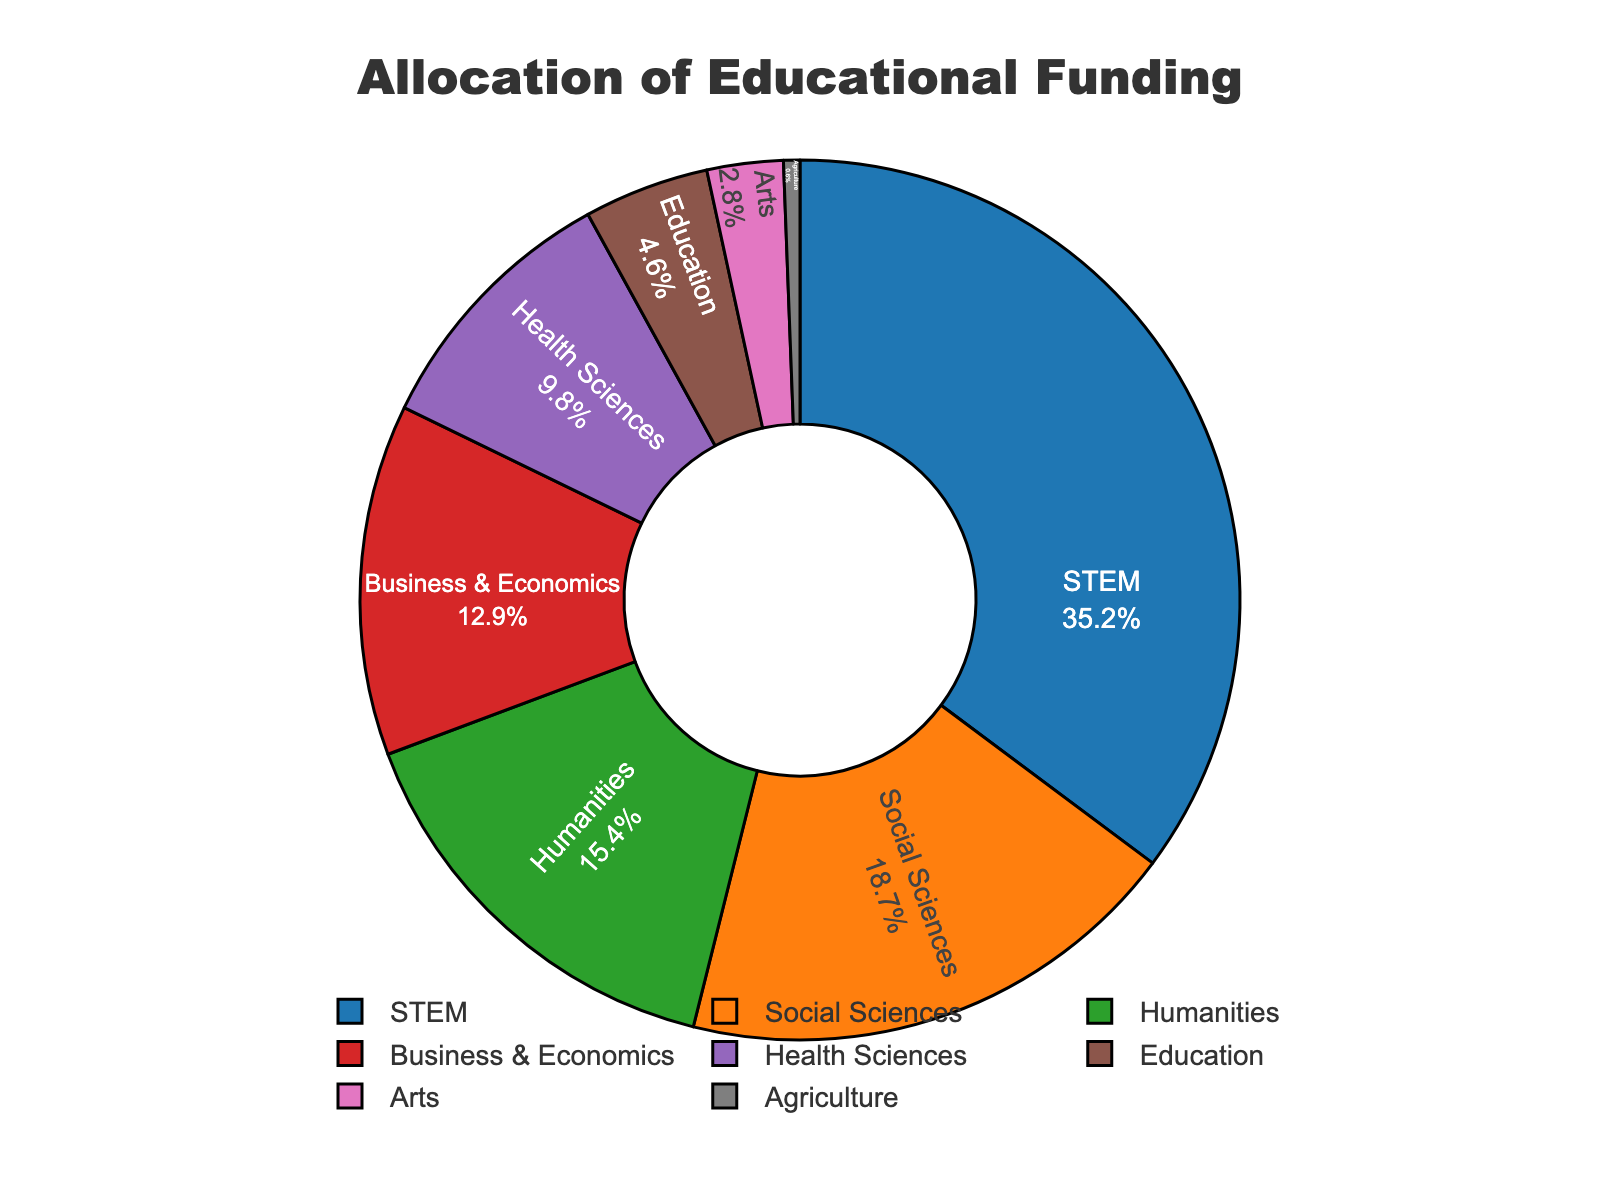Which discipline receives the highest percentage of educational funding? From the pie chart, the discipline with the largest slice is clearly labeled as STEM. Therefore, STEM receives the highest percentage of educational funding.
Answer: STEM What is the total percentage of funding allocated to the Social Sciences and Humanities combined? To find the combined percentage for Social Sciences and Humanities, add their individual percentages: 18.7% (Social Sciences) + 15.4% (Humanities) = 34.1%.
Answer: 34.1% How much more funding does the STEM discipline receive compared to Health Sciences? Subtract the percentage for Health Sciences from that for STEM: 35.2% (STEM) - 9.8% (Health Sciences) = 25.4%.
Answer: 25.4% What is the least-funded discipline and its percentage of the total allocation? The smallest slice in the pie chart is labeled Agriculture with the smallest percentage. The figure shows it receives 0.6% of the total allocation.
Answer: Agriculture, 0.6% Considering the disciplines of Business & Economics and Education, which one receives more funding and by how much? Compare the percentages for Business & Economics and Education: 12.9% (Business & Economics) and 4.6% (Education). To find the difference, subtract 4.6% from 12.9%: 12.9% - 4.6% = 8.3%. Business & Economics receives more funding.
Answer: Business & Economics, 8.3% What is the sum of the funding percentages for disciplines that receive less than 10% of the total allocation each? Identify the disciplines receiving less than 10% each: Health Sciences (9.8%), Education (4.6%), Arts (2.8%), and Agriculture (0.6%). Add these percentages: 9.8% + 4.6% + 2.8% + 0.6% = 17.8%.
Answer: 17.8% How is the funding for Arts visually represented compared to STEM? Visually, the slice for Arts is significantly smaller than the slice for STEM, indicating much less funding for Arts. The specific colors can also aid in distinguishing these portions: Assumed from the color distribution in the figure, Arts might be one of the last colors in the custom palette used.
Answer: Smaller slice for Arts Which discipline has a slightly higher percentage of the funding: Humanities or Business & Economics? Compare the percentages for the two disciplines: Humanities (15.4%) and Business & Economics (12.9%). Humanities has a higher percentage.
Answer: Humanities 